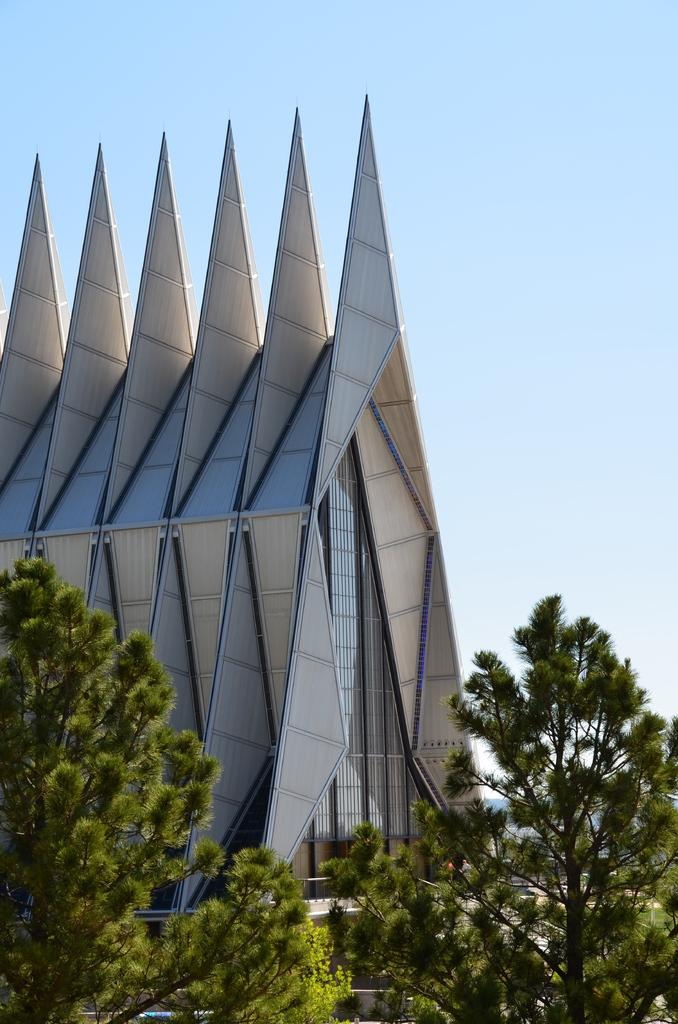What type of structure is present in the image? There is a building in the image. What other natural elements can be seen in the image? There are trees in the image. What is visible at the top of the image? The sky is visible at the top of the image. What type of meal is being served in the image? There is no meal present in the image; it only features a building, trees, and the sky. 